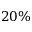<formula> <loc_0><loc_0><loc_500><loc_500>2 0 \%</formula> 